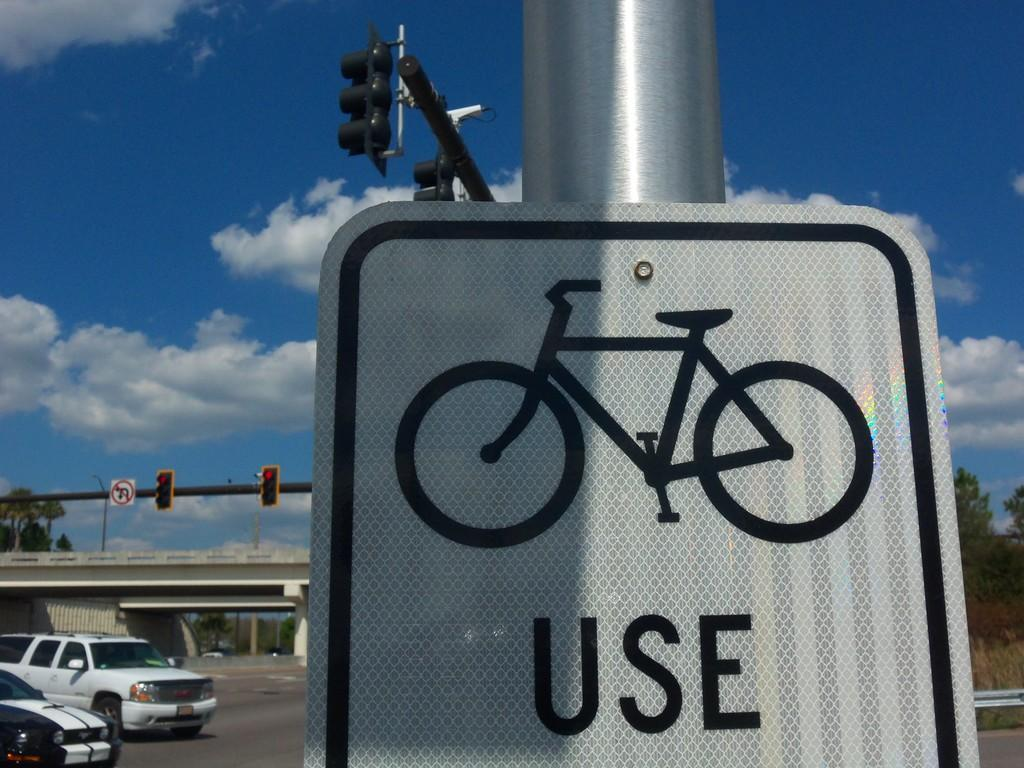<image>
Describe the image concisely. A white and black sign with a picture of a bike with the word use on the bottom. 